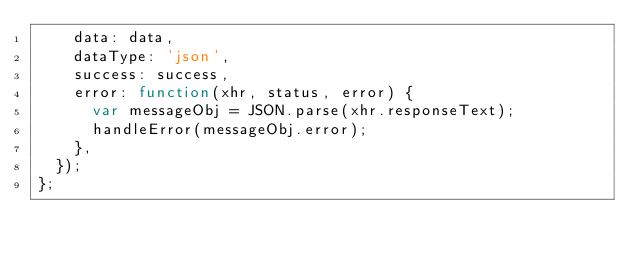<code> <loc_0><loc_0><loc_500><loc_500><_JavaScript_>    data: data,
    dataType: 'json',
    success: success,
    error: function(xhr, status, error) {
      var messageObj = JSON.parse(xhr.responseText);
      handleError(messageObj.error);
    },
  });
};
</code> 